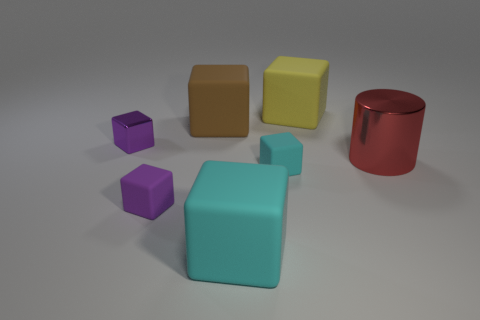Add 2 large red things. How many objects exist? 9 Subtract all cyan matte cubes. How many cubes are left? 4 Subtract all cubes. How many objects are left? 1 Subtract all cyan cubes. How many cubes are left? 4 Subtract 1 cylinders. How many cylinders are left? 0 Add 6 big cyan rubber objects. How many big cyan rubber objects are left? 7 Add 3 small purple metallic blocks. How many small purple metallic blocks exist? 4 Subtract 0 brown spheres. How many objects are left? 7 Subtract all brown blocks. Subtract all purple spheres. How many blocks are left? 5 Subtract all green cubes. How many purple cylinders are left? 0 